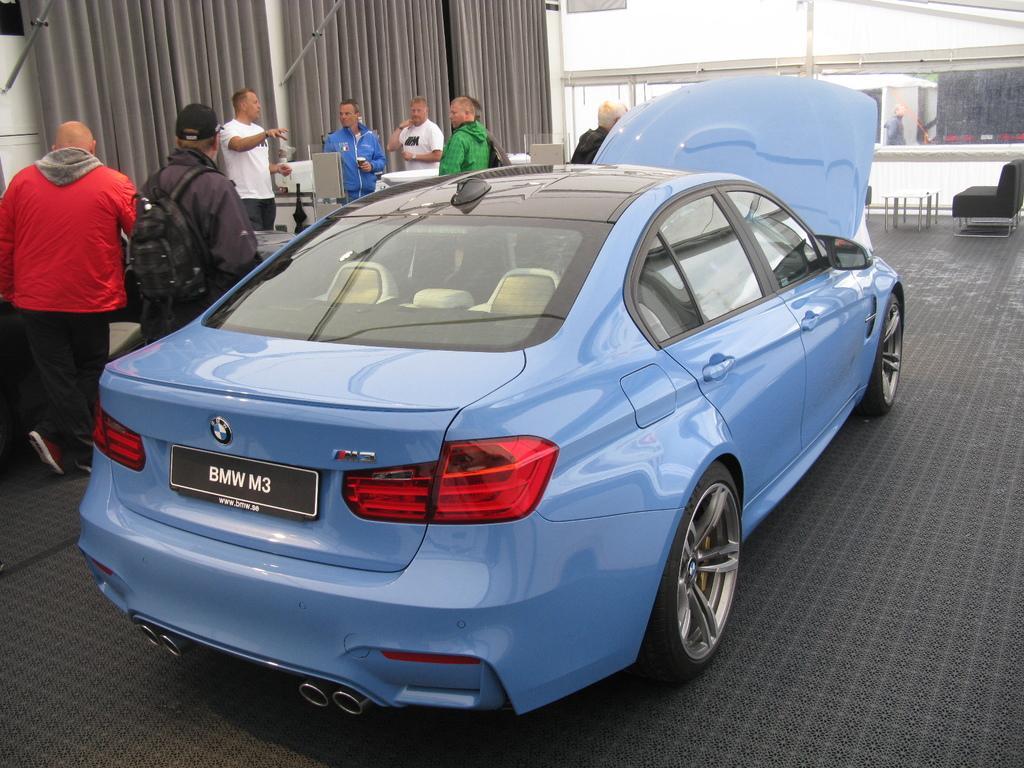Describe this image in one or two sentences. It is a beautiful car which is in blue color, in the left side a man is standing, he wore a red color coat and few other people are standing at here. In the right side there is a sofa which is in black color. 